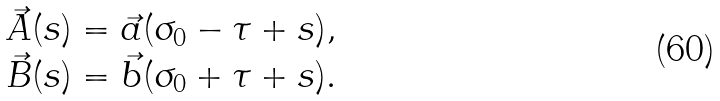<formula> <loc_0><loc_0><loc_500><loc_500>\begin{array} { l } \vec { A } ( s ) = \vec { a } ( \sigma _ { 0 } - \tau + s ) , \\ \vec { B } ( s ) = \vec { b } ( \sigma _ { 0 } + \tau + s ) . \end{array}</formula> 